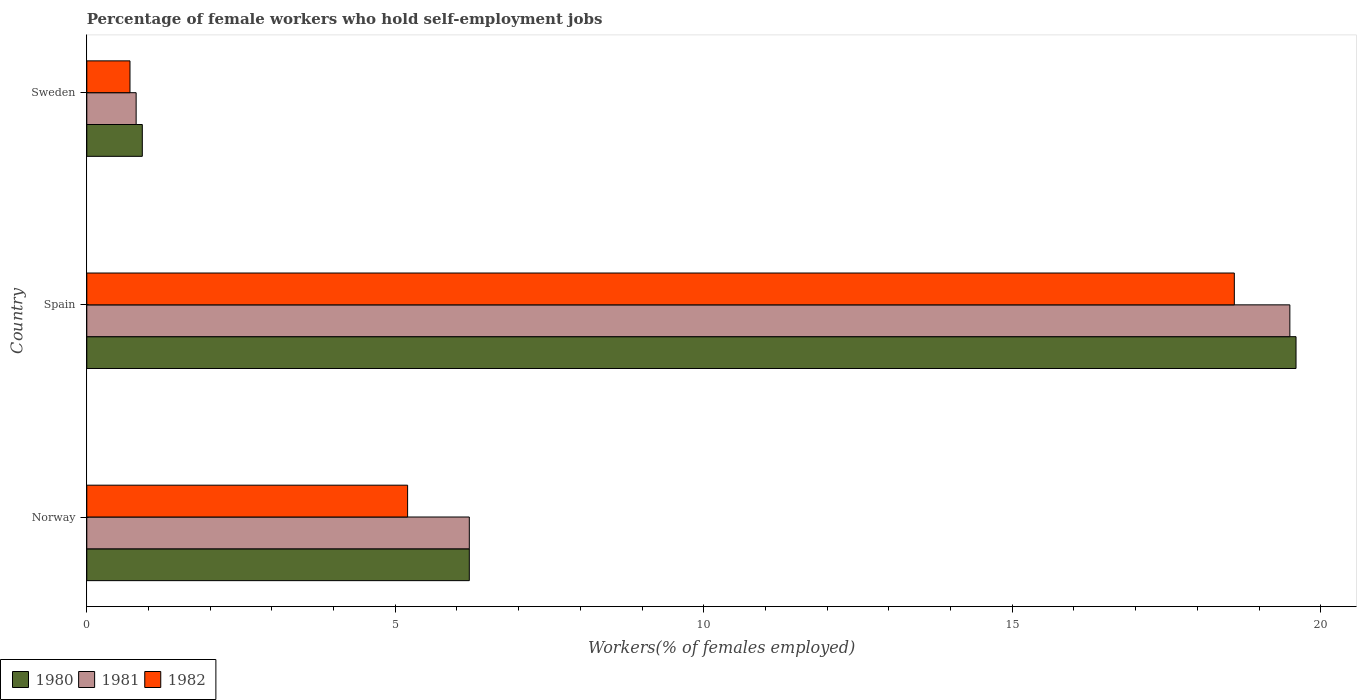How many different coloured bars are there?
Provide a short and direct response. 3. Are the number of bars per tick equal to the number of legend labels?
Ensure brevity in your answer.  Yes. Are the number of bars on each tick of the Y-axis equal?
Give a very brief answer. Yes. What is the label of the 2nd group of bars from the top?
Keep it short and to the point. Spain. In how many cases, is the number of bars for a given country not equal to the number of legend labels?
Keep it short and to the point. 0. What is the percentage of self-employed female workers in 1981 in Norway?
Ensure brevity in your answer.  6.2. Across all countries, what is the maximum percentage of self-employed female workers in 1981?
Make the answer very short. 19.5. Across all countries, what is the minimum percentage of self-employed female workers in 1981?
Your response must be concise. 0.8. In which country was the percentage of self-employed female workers in 1982 minimum?
Offer a terse response. Sweden. What is the total percentage of self-employed female workers in 1980 in the graph?
Ensure brevity in your answer.  26.7. What is the difference between the percentage of self-employed female workers in 1982 in Norway and that in Spain?
Your answer should be very brief. -13.4. What is the difference between the percentage of self-employed female workers in 1981 in Spain and the percentage of self-employed female workers in 1980 in Sweden?
Ensure brevity in your answer.  18.6. What is the average percentage of self-employed female workers in 1981 per country?
Give a very brief answer. 8.83. What is the difference between the percentage of self-employed female workers in 1981 and percentage of self-employed female workers in 1982 in Norway?
Give a very brief answer. 1. In how many countries, is the percentage of self-employed female workers in 1980 greater than 4 %?
Provide a succinct answer. 2. What is the ratio of the percentage of self-employed female workers in 1980 in Spain to that in Sweden?
Ensure brevity in your answer.  21.78. Is the difference between the percentage of self-employed female workers in 1981 in Spain and Sweden greater than the difference between the percentage of self-employed female workers in 1982 in Spain and Sweden?
Make the answer very short. Yes. What is the difference between the highest and the second highest percentage of self-employed female workers in 1982?
Your answer should be very brief. 13.4. What is the difference between the highest and the lowest percentage of self-employed female workers in 1982?
Offer a very short reply. 17.9. In how many countries, is the percentage of self-employed female workers in 1980 greater than the average percentage of self-employed female workers in 1980 taken over all countries?
Your response must be concise. 1. What does the 2nd bar from the bottom in Norway represents?
Provide a succinct answer. 1981. Is it the case that in every country, the sum of the percentage of self-employed female workers in 1982 and percentage of self-employed female workers in 1980 is greater than the percentage of self-employed female workers in 1981?
Your response must be concise. Yes. How many bars are there?
Ensure brevity in your answer.  9. Are all the bars in the graph horizontal?
Keep it short and to the point. Yes. How many countries are there in the graph?
Offer a very short reply. 3. What is the difference between two consecutive major ticks on the X-axis?
Ensure brevity in your answer.  5. Does the graph contain any zero values?
Ensure brevity in your answer.  No. Does the graph contain grids?
Your answer should be very brief. No. Where does the legend appear in the graph?
Your response must be concise. Bottom left. What is the title of the graph?
Provide a succinct answer. Percentage of female workers who hold self-employment jobs. What is the label or title of the X-axis?
Provide a succinct answer. Workers(% of females employed). What is the label or title of the Y-axis?
Your response must be concise. Country. What is the Workers(% of females employed) in 1980 in Norway?
Offer a terse response. 6.2. What is the Workers(% of females employed) in 1981 in Norway?
Offer a terse response. 6.2. What is the Workers(% of females employed) in 1982 in Norway?
Offer a very short reply. 5.2. What is the Workers(% of females employed) in 1980 in Spain?
Offer a terse response. 19.6. What is the Workers(% of females employed) of 1981 in Spain?
Ensure brevity in your answer.  19.5. What is the Workers(% of females employed) in 1982 in Spain?
Your answer should be very brief. 18.6. What is the Workers(% of females employed) in 1980 in Sweden?
Your answer should be very brief. 0.9. What is the Workers(% of females employed) in 1981 in Sweden?
Offer a terse response. 0.8. What is the Workers(% of females employed) of 1982 in Sweden?
Make the answer very short. 0.7. Across all countries, what is the maximum Workers(% of females employed) of 1980?
Give a very brief answer. 19.6. Across all countries, what is the maximum Workers(% of females employed) of 1981?
Provide a succinct answer. 19.5. Across all countries, what is the maximum Workers(% of females employed) of 1982?
Keep it short and to the point. 18.6. Across all countries, what is the minimum Workers(% of females employed) of 1980?
Your answer should be compact. 0.9. Across all countries, what is the minimum Workers(% of females employed) of 1981?
Your answer should be very brief. 0.8. Across all countries, what is the minimum Workers(% of females employed) of 1982?
Make the answer very short. 0.7. What is the total Workers(% of females employed) of 1980 in the graph?
Your answer should be very brief. 26.7. What is the difference between the Workers(% of females employed) in 1981 in Spain and that in Sweden?
Make the answer very short. 18.7. What is the difference between the Workers(% of females employed) of 1982 in Spain and that in Sweden?
Your answer should be compact. 17.9. What is the difference between the Workers(% of females employed) of 1980 in Norway and the Workers(% of females employed) of 1981 in Spain?
Provide a succinct answer. -13.3. What is the difference between the Workers(% of females employed) of 1980 in Norway and the Workers(% of females employed) of 1982 in Spain?
Your answer should be compact. -12.4. What is the difference between the Workers(% of females employed) of 1981 in Norway and the Workers(% of females employed) of 1982 in Spain?
Ensure brevity in your answer.  -12.4. What is the difference between the Workers(% of females employed) of 1980 in Norway and the Workers(% of females employed) of 1981 in Sweden?
Your answer should be very brief. 5.4. What is the difference between the Workers(% of females employed) in 1981 in Norway and the Workers(% of females employed) in 1982 in Sweden?
Your answer should be very brief. 5.5. What is the difference between the Workers(% of females employed) of 1980 in Spain and the Workers(% of females employed) of 1982 in Sweden?
Your answer should be compact. 18.9. What is the average Workers(% of females employed) of 1980 per country?
Your answer should be very brief. 8.9. What is the average Workers(% of females employed) of 1981 per country?
Provide a short and direct response. 8.83. What is the average Workers(% of females employed) of 1982 per country?
Your response must be concise. 8.17. What is the difference between the Workers(% of females employed) in 1980 and Workers(% of females employed) in 1981 in Norway?
Ensure brevity in your answer.  0. What is the difference between the Workers(% of females employed) of 1980 and Workers(% of females employed) of 1982 in Norway?
Offer a terse response. 1. What is the difference between the Workers(% of females employed) of 1980 and Workers(% of females employed) of 1981 in Spain?
Your answer should be compact. 0.1. What is the difference between the Workers(% of females employed) in 1981 and Workers(% of females employed) in 1982 in Spain?
Provide a succinct answer. 0.9. What is the difference between the Workers(% of females employed) in 1980 and Workers(% of females employed) in 1982 in Sweden?
Make the answer very short. 0.2. What is the ratio of the Workers(% of females employed) in 1980 in Norway to that in Spain?
Offer a very short reply. 0.32. What is the ratio of the Workers(% of females employed) of 1981 in Norway to that in Spain?
Give a very brief answer. 0.32. What is the ratio of the Workers(% of females employed) in 1982 in Norway to that in Spain?
Your response must be concise. 0.28. What is the ratio of the Workers(% of females employed) in 1980 in Norway to that in Sweden?
Your response must be concise. 6.89. What is the ratio of the Workers(% of females employed) of 1981 in Norway to that in Sweden?
Your answer should be very brief. 7.75. What is the ratio of the Workers(% of females employed) in 1982 in Norway to that in Sweden?
Give a very brief answer. 7.43. What is the ratio of the Workers(% of females employed) in 1980 in Spain to that in Sweden?
Offer a terse response. 21.78. What is the ratio of the Workers(% of females employed) in 1981 in Spain to that in Sweden?
Your response must be concise. 24.38. What is the ratio of the Workers(% of females employed) of 1982 in Spain to that in Sweden?
Provide a short and direct response. 26.57. What is the difference between the highest and the second highest Workers(% of females employed) of 1980?
Your answer should be compact. 13.4. What is the difference between the highest and the second highest Workers(% of females employed) in 1982?
Your answer should be compact. 13.4. What is the difference between the highest and the lowest Workers(% of females employed) in 1981?
Provide a short and direct response. 18.7. What is the difference between the highest and the lowest Workers(% of females employed) of 1982?
Ensure brevity in your answer.  17.9. 